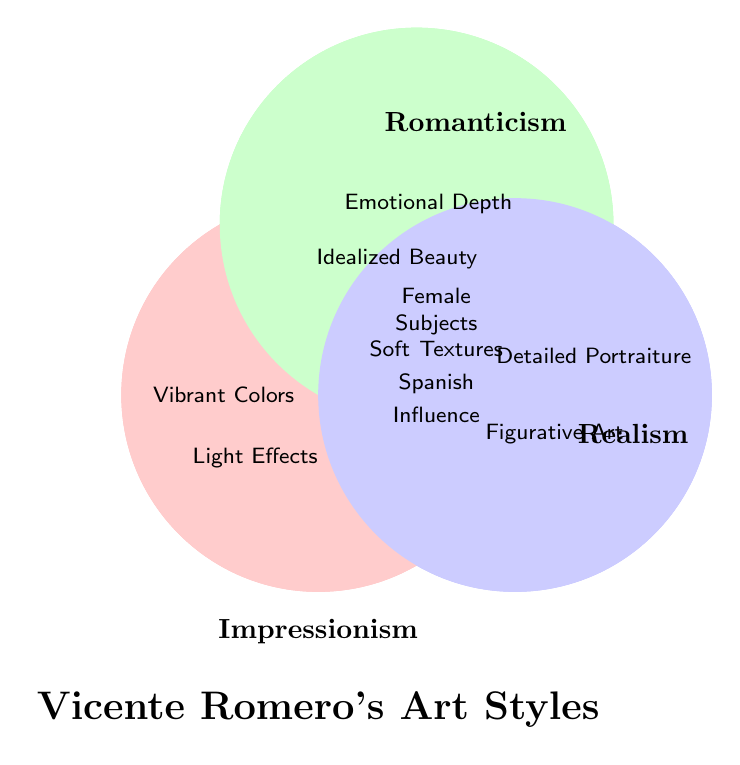What are the three art styles shown in the diagram? The diagram shows three overlapping circles labeled with different art styles. The labels are 'Impressionism', 'Romanticism', and 'Realism'.
Answer: Impressionism, Romanticism, Realism Which art style uses "Vibrant Colors"? The label "Vibrant Colors" is inside the circle labeled "Impressionism".
Answer: Impressionism How many styles include "Female Subjects"? "Female Subjects" is located in the intersection of all three circles. This means it is included in all three art styles: Impressionism, Romanticism, and Realism.
Answer: Three What is the color of the circle labeled "Romanticism"? The circle labeled "Romanticism" is shaded in green.
Answer: Green Which art style incorporates "Detailed Portraiture"? The label "Detailed Portraiture" is inside the circle labeled "Realism".
Answer: Realism Do "Light Effects" and "Emotional Depth" belong to the same art style? "Light Effects" is in the Impressionism circle, and "Emotional Depth" is in the Romanticism circle. Since they are in different circles, they don't belong to the same art style.
Answer: No Which style emphasizes "Emotional Depth" and "Idealized Beauty"? Both "Emotional Depth" and "Idealized Beauty" are inside the circle labeled "Romanticism".
Answer: Romanticism How many unique attributes does Realism have? There are two attributes falling exclusively within the Realism circle: "Detailed Portraiture" and "Figurative Art".
Answer: Two Which attribute appears in all three art styles but hasn't been mentioned yet? The attributes located in the intersection visually represent those present in all styles. These attributes are "Female Subjects," "Soft Textures," and "Spanish Influence."
Answer: Soft Textures, Spanish Influence 